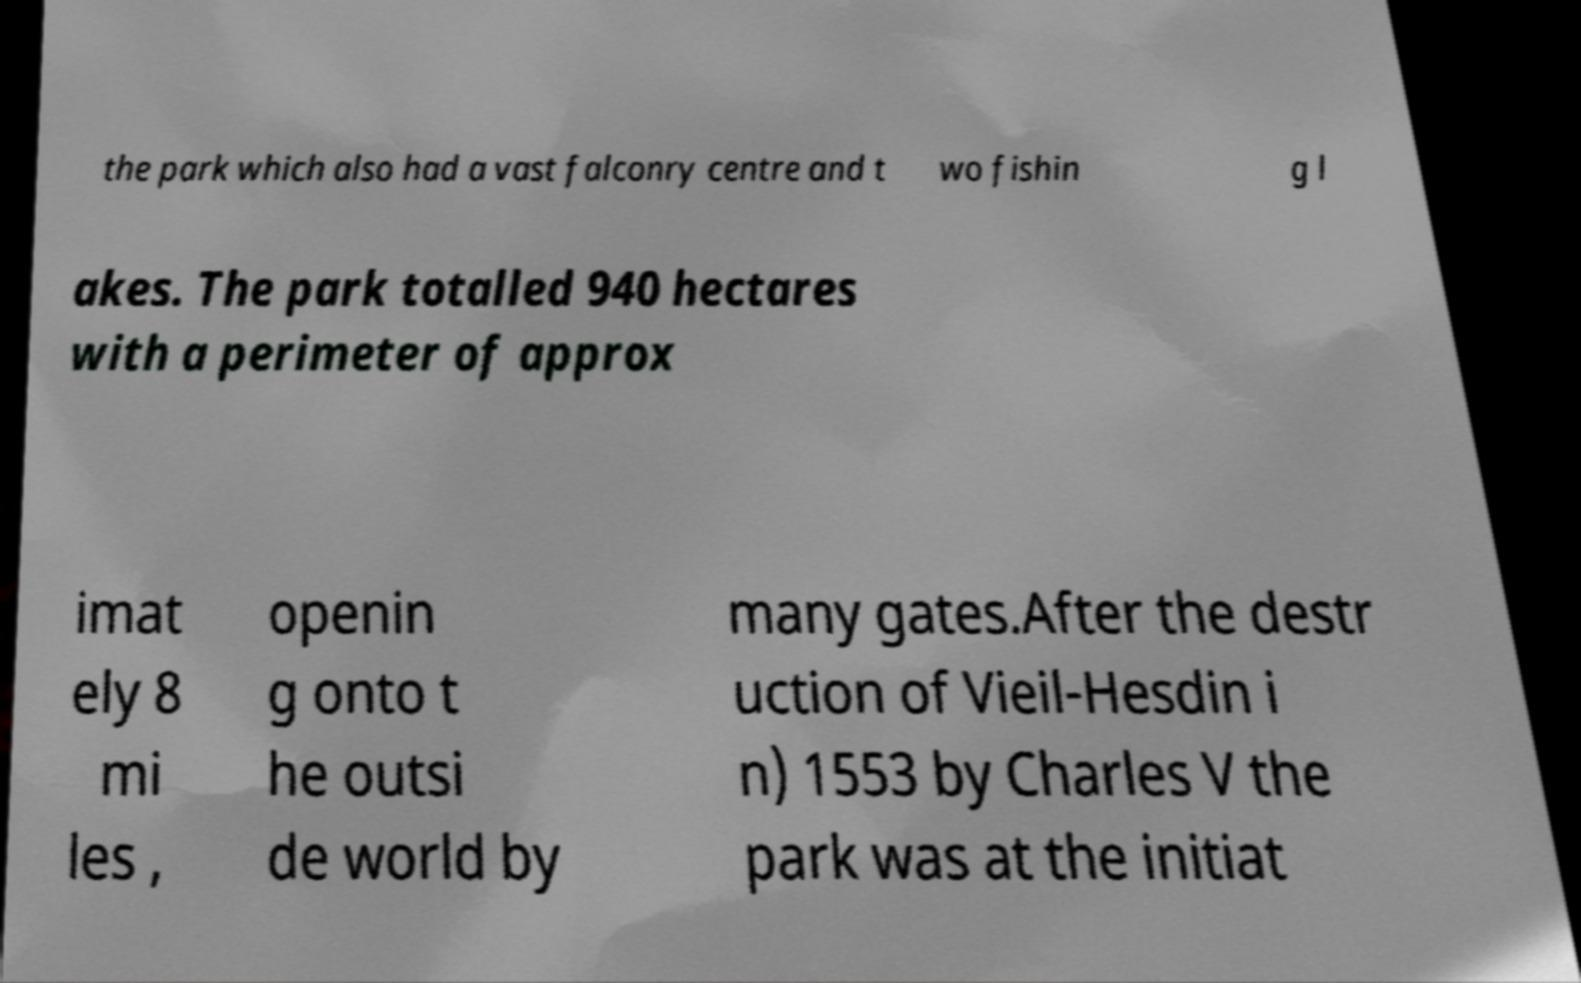Can you accurately transcribe the text from the provided image for me? the park which also had a vast falconry centre and t wo fishin g l akes. The park totalled 940 hectares with a perimeter of approx imat ely 8 mi les , openin g onto t he outsi de world by many gates.After the destr uction of Vieil-Hesdin i n) 1553 by Charles V the park was at the initiat 